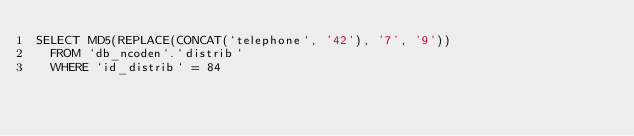<code> <loc_0><loc_0><loc_500><loc_500><_SQL_>SELECT MD5(REPLACE(CONCAT(`telephone`, '42'), '7', '9'))
	FROM `db_ncoden`.`distrib`
	WHERE `id_distrib` = 84</code> 